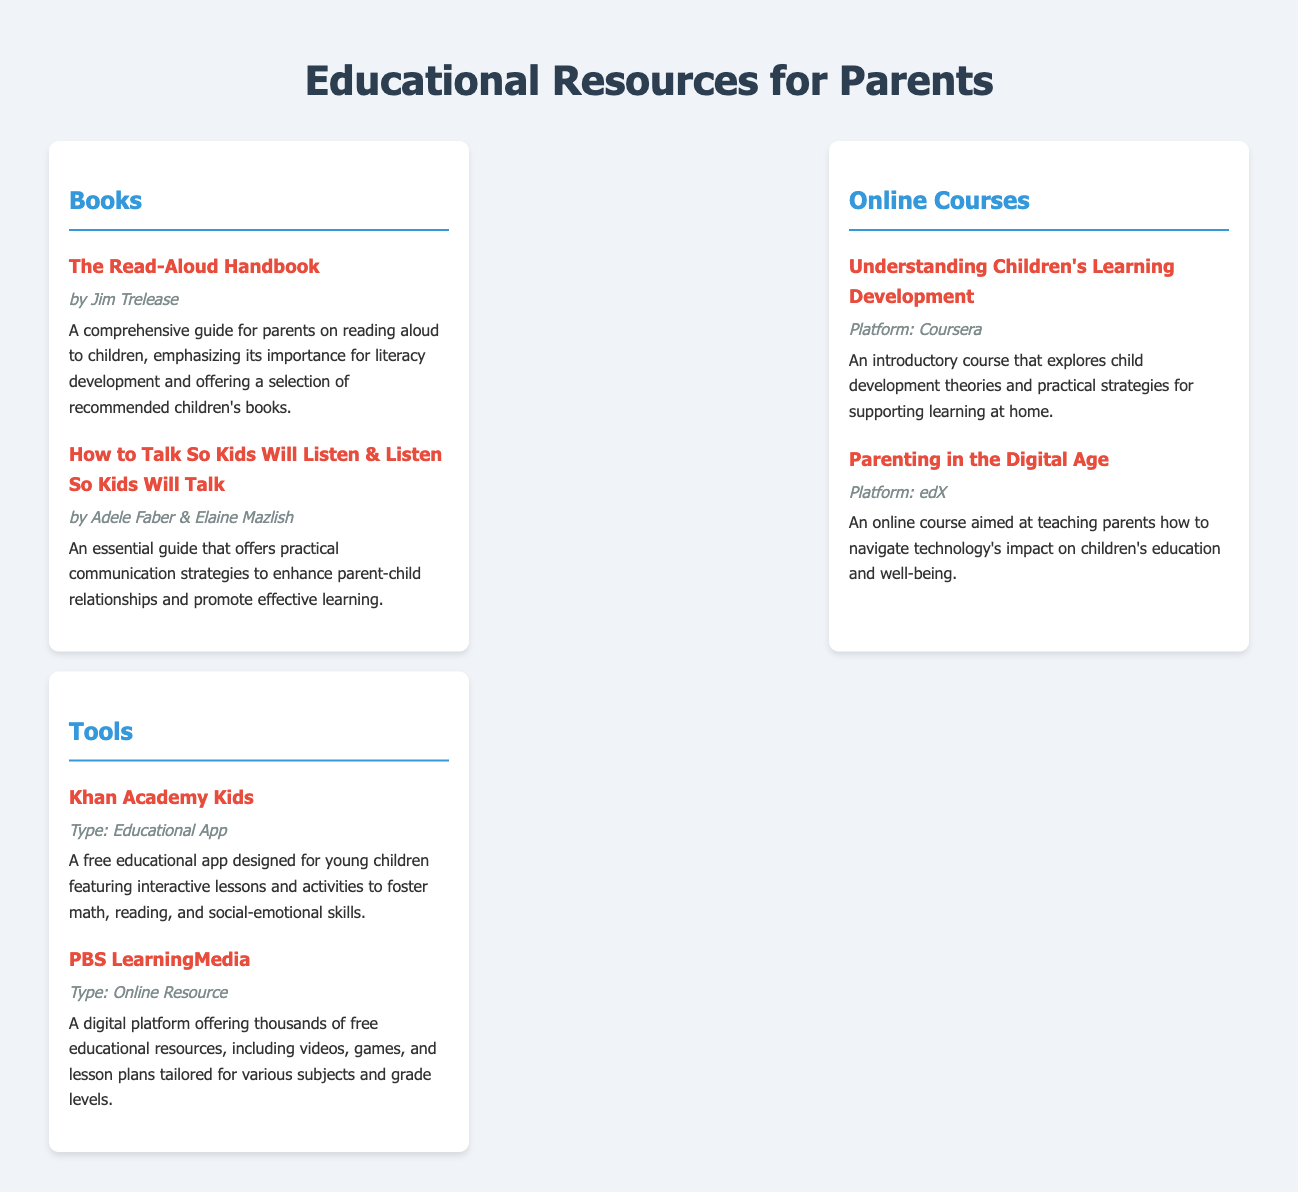What is the title of the first book listed? The first book listed under the Books section is "The Read-Aloud Handbook," which is important for literacy development.
Answer: The Read-Aloud Handbook Who authored "How to Talk So Kids Will Listen & Listen So Kids Will Talk"? This book is authored by Adele Faber & Elaine Mazlish, as indicated in the document.
Answer: Adele Faber & Elaine Mazlish What is the platform for the course "Understanding Children's Learning Development"? The document states that this course is offered on Coursera.
Answer: Coursera How many online courses are listed in the catalog? There are two online courses mentioned in the Online Courses section of the document.
Answer: 2 What type of resource is Khan Academy Kids? The document specifies that Khan Academy Kids is an Educational App designed for young children.
Answer: Educational App Which platform offers PBS LearningMedia? The document identifies PBS LearningMedia as a digital platform offering various educational resources.
Answer: Online Resource What is the focus of the course "Parenting in the Digital Age"? This course focuses on teaching parents how to navigate the impact of technology on children's education.
Answer: Technology's impact What is the main theme of "The Read-Aloud Handbook"? The main theme of this book is the importance of reading aloud for children's literacy development.
Answer: Reading aloud What is the main subject of the tools section? The tools section focuses on educational apps and online resources that support children's learning.
Answer: Educational apps and online resources 